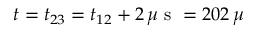<formula> <loc_0><loc_0><loc_500><loc_500>t = t _ { 2 3 } = t _ { 1 2 } + 2 \, \mu s = 2 0 2 \, \mu</formula> 